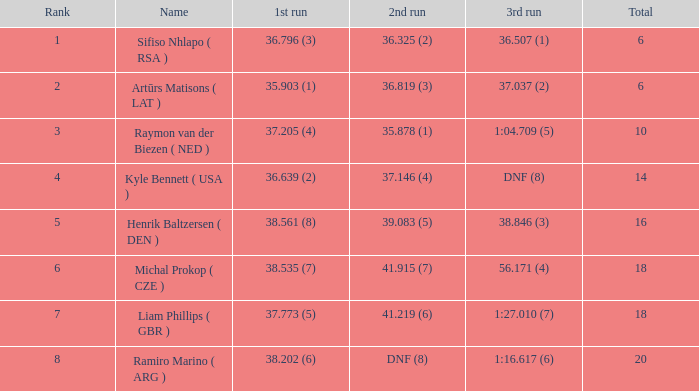Which average rank has a total of 16? 5.0. 